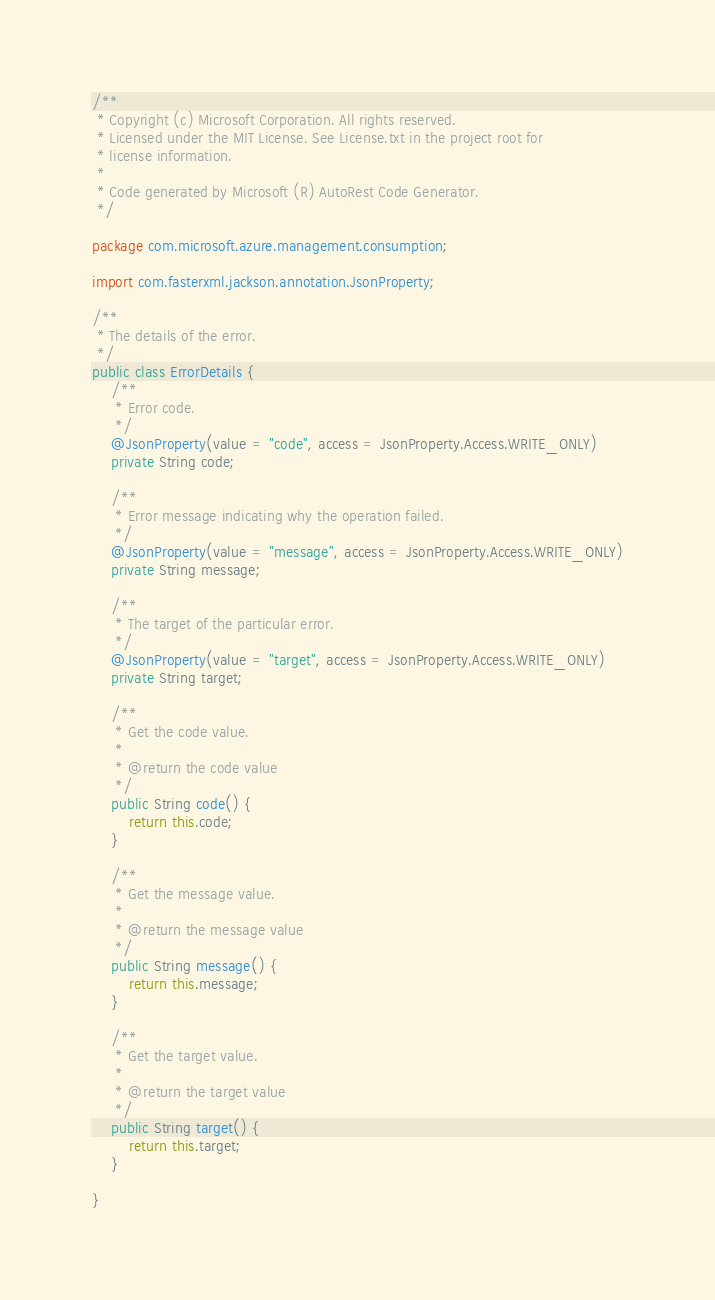<code> <loc_0><loc_0><loc_500><loc_500><_Java_>/**
 * Copyright (c) Microsoft Corporation. All rights reserved.
 * Licensed under the MIT License. See License.txt in the project root for
 * license information.
 *
 * Code generated by Microsoft (R) AutoRest Code Generator.
 */

package com.microsoft.azure.management.consumption;

import com.fasterxml.jackson.annotation.JsonProperty;

/**
 * The details of the error.
 */
public class ErrorDetails {
    /**
     * Error code.
     */
    @JsonProperty(value = "code", access = JsonProperty.Access.WRITE_ONLY)
    private String code;

    /**
     * Error message indicating why the operation failed.
     */
    @JsonProperty(value = "message", access = JsonProperty.Access.WRITE_ONLY)
    private String message;

    /**
     * The target of the particular error.
     */
    @JsonProperty(value = "target", access = JsonProperty.Access.WRITE_ONLY)
    private String target;

    /**
     * Get the code value.
     *
     * @return the code value
     */
    public String code() {
        return this.code;
    }

    /**
     * Get the message value.
     *
     * @return the message value
     */
    public String message() {
        return this.message;
    }

    /**
     * Get the target value.
     *
     * @return the target value
     */
    public String target() {
        return this.target;
    }

}
</code> 